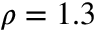Convert formula to latex. <formula><loc_0><loc_0><loc_500><loc_500>\rho = 1 . 3</formula> 